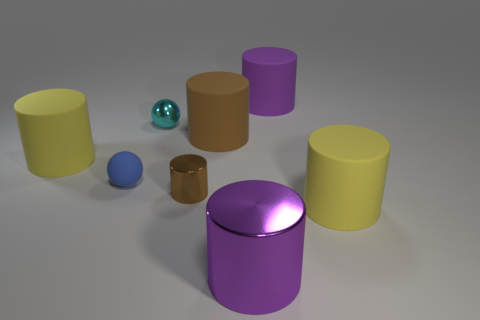Is the blue ball made of the same material as the cyan sphere?
Provide a succinct answer. No. Is there another cylinder of the same color as the small cylinder?
Provide a short and direct response. Yes. What number of things are small brown shiny things or metallic cylinders left of the large purple shiny object?
Your answer should be compact. 1. What number of cylinders are behind the big purple cylinder that is in front of the matte thing in front of the tiny blue matte sphere?
Offer a terse response. 5. What number of purple metal objects are there?
Your answer should be very brief. 1. There is a yellow thing that is to the right of the cyan ball; does it have the same size as the blue matte object?
Ensure brevity in your answer.  No. How many shiny objects are either purple cylinders or brown cylinders?
Provide a succinct answer. 2. How many brown cylinders are behind the small object to the right of the shiny ball?
Provide a short and direct response. 1. What is the shape of the matte thing that is to the right of the big brown matte thing and behind the small brown cylinder?
Your answer should be very brief. Cylinder. There is a small sphere that is behind the brown rubber thing that is behind the yellow cylinder to the left of the purple matte object; what is its material?
Your response must be concise. Metal. 